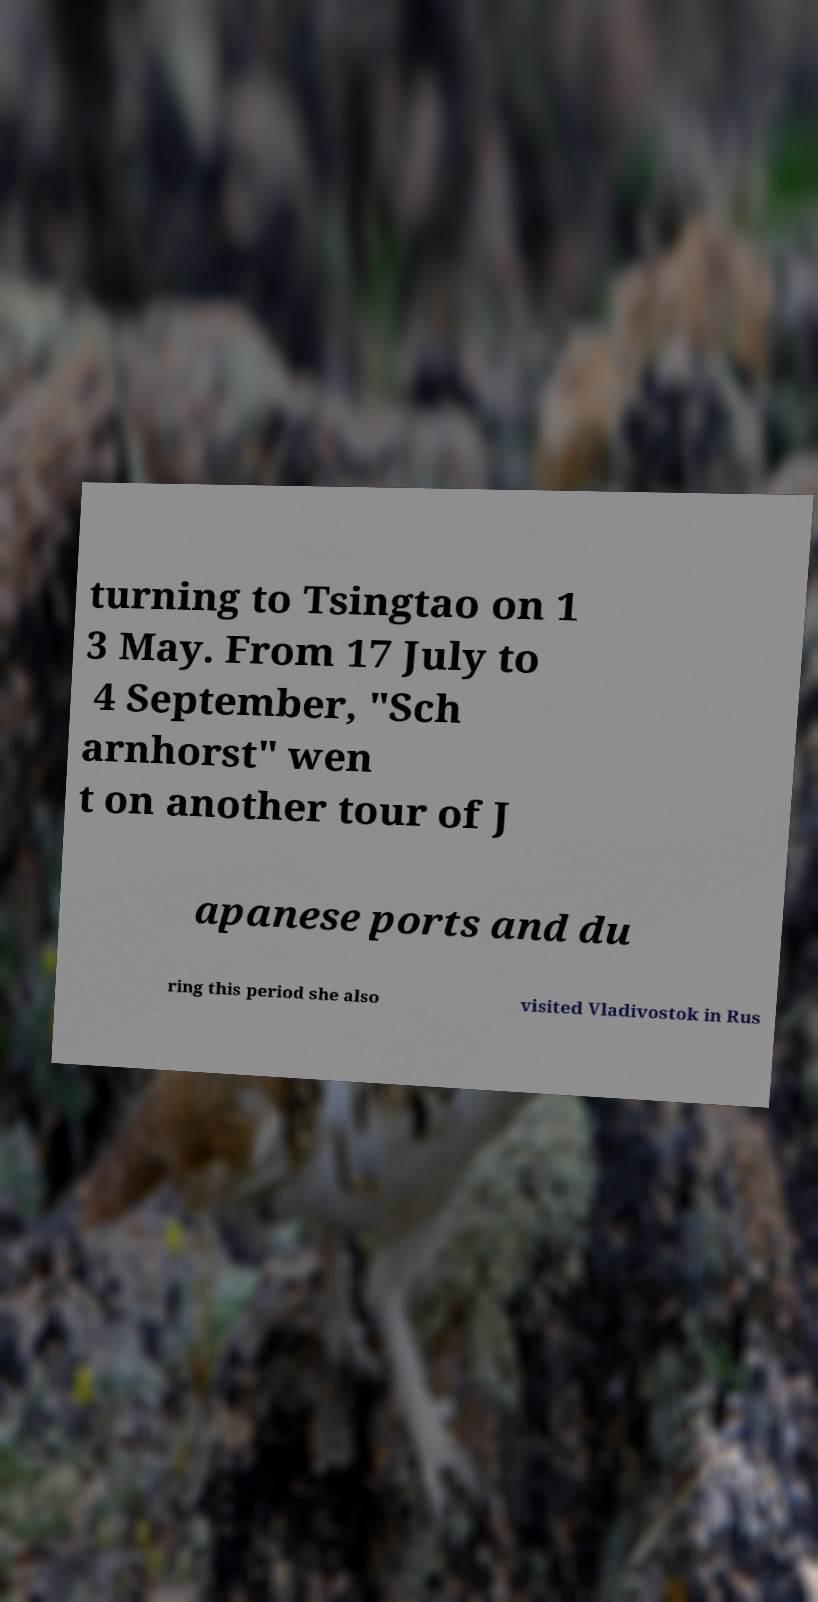Please identify and transcribe the text found in this image. turning to Tsingtao on 1 3 May. From 17 July to 4 September, "Sch arnhorst" wen t on another tour of J apanese ports and du ring this period she also visited Vladivostok in Rus 